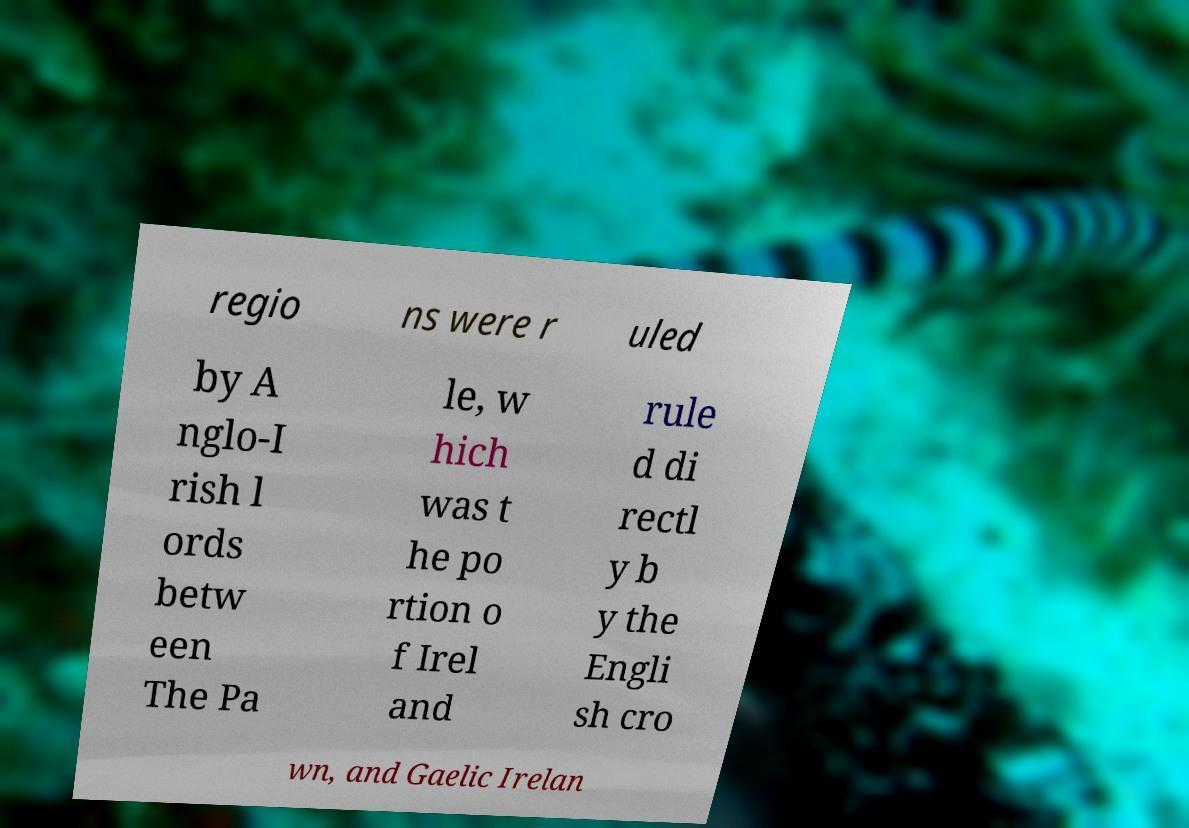I need the written content from this picture converted into text. Can you do that? regio ns were r uled by A nglo-I rish l ords betw een The Pa le, w hich was t he po rtion o f Irel and rule d di rectl y b y the Engli sh cro wn, and Gaelic Irelan 